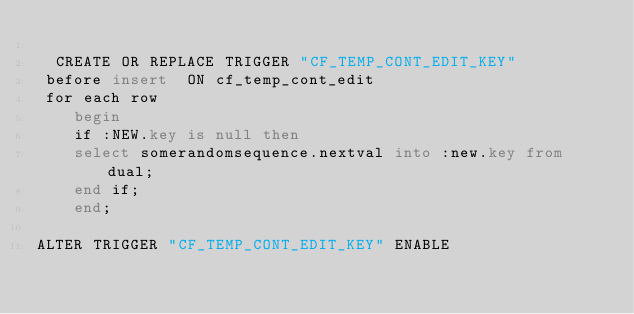<code> <loc_0><loc_0><loc_500><loc_500><_SQL_>
  CREATE OR REPLACE TRIGGER "CF_TEMP_CONT_EDIT_KEY" 
 before insert  ON cf_temp_cont_edit
 for each row
    begin
    if :NEW.key is null then
    select somerandomsequence.nextval into :new.key from dual;
    end if;
    end;

ALTER TRIGGER "CF_TEMP_CONT_EDIT_KEY" ENABLE</code> 